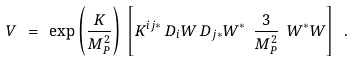Convert formula to latex. <formula><loc_0><loc_0><loc_500><loc_500>V \ = \ \exp \left ( { \frac { K } { M _ { P } ^ { 2 } } } \right ) \, \left [ K ^ { i j * } \, D _ { i } W \, D _ { j * } W ^ { * } \ { \frac { 3 } { M _ { P } ^ { 2 } } } \ W ^ { * } W \right ] \ .</formula> 